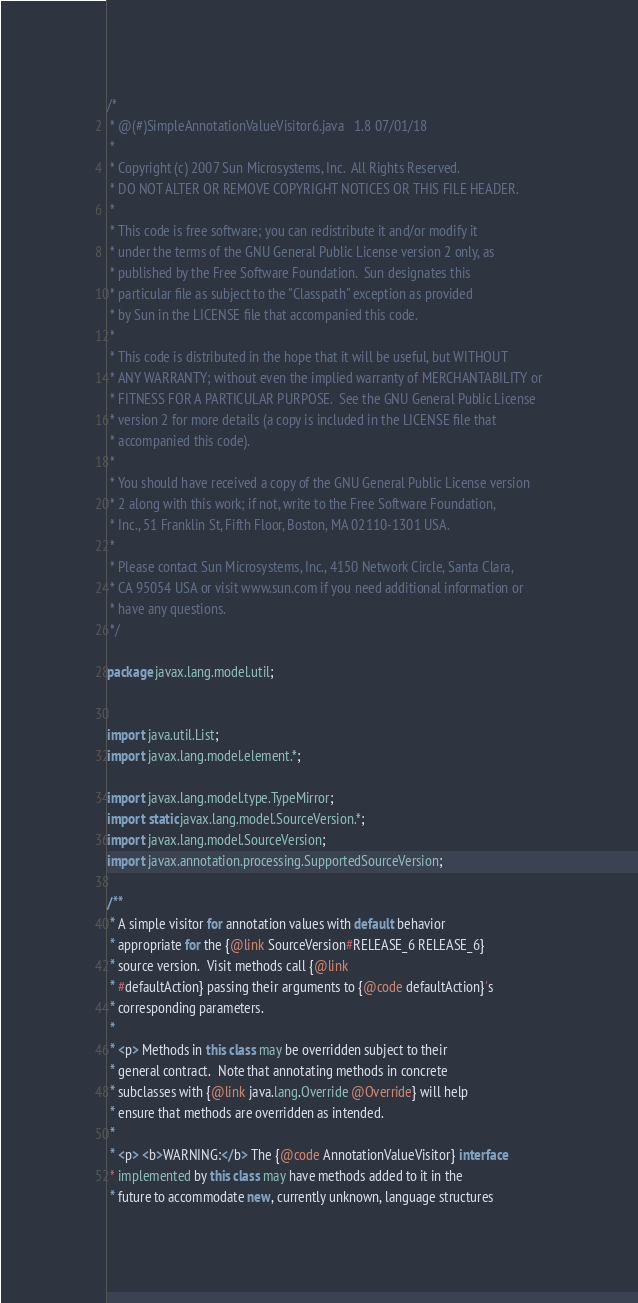Convert code to text. <code><loc_0><loc_0><loc_500><loc_500><_Java_>/*
 * @(#)SimpleAnnotationValueVisitor6.java	1.8 07/01/18
 * 
 * Copyright (c) 2007 Sun Microsystems, Inc.  All Rights Reserved.
 * DO NOT ALTER OR REMOVE COPYRIGHT NOTICES OR THIS FILE HEADER.
 *  
 * This code is free software; you can redistribute it and/or modify it
 * under the terms of the GNU General Public License version 2 only, as
 * published by the Free Software Foundation.  Sun designates this
 * particular file as subject to the "Classpath" exception as provided
 * by Sun in the LICENSE file that accompanied this code.
 *  
 * This code is distributed in the hope that it will be useful, but WITHOUT
 * ANY WARRANTY; without even the implied warranty of MERCHANTABILITY or
 * FITNESS FOR A PARTICULAR PURPOSE.  See the GNU General Public License
 * version 2 for more details (a copy is included in the LICENSE file that
 * accompanied this code).
 *  
 * You should have received a copy of the GNU General Public License version
 * 2 along with this work; if not, write to the Free Software Foundation,
 * Inc., 51 Franklin St, Fifth Floor, Boston, MA 02110-1301 USA.
 *  
 * Please contact Sun Microsystems, Inc., 4150 Network Circle, Santa Clara,
 * CA 95054 USA or visit www.sun.com if you need additional information or
 * have any questions.
 */

package javax.lang.model.util;


import java.util.List;
import javax.lang.model.element.*;

import javax.lang.model.type.TypeMirror;
import static javax.lang.model.SourceVersion.*;
import javax.lang.model.SourceVersion;
import javax.annotation.processing.SupportedSourceVersion;

/**
 * A simple visitor for annotation values with default behavior
 * appropriate for the {@link SourceVersion#RELEASE_6 RELEASE_6}
 * source version.  Visit methods call {@link
 * #defaultAction} passing their arguments to {@code defaultAction}'s
 * corresponding parameters.
 *
 * <p> Methods in this class may be overridden subject to their
 * general contract.  Note that annotating methods in concrete
 * subclasses with {@link java.lang.Override @Override} will help
 * ensure that methods are overridden as intended.
 *
 * <p> <b>WARNING:</b> The {@code AnnotationValueVisitor} interface
 * implemented by this class may have methods added to it in the
 * future to accommodate new, currently unknown, language structures</code> 